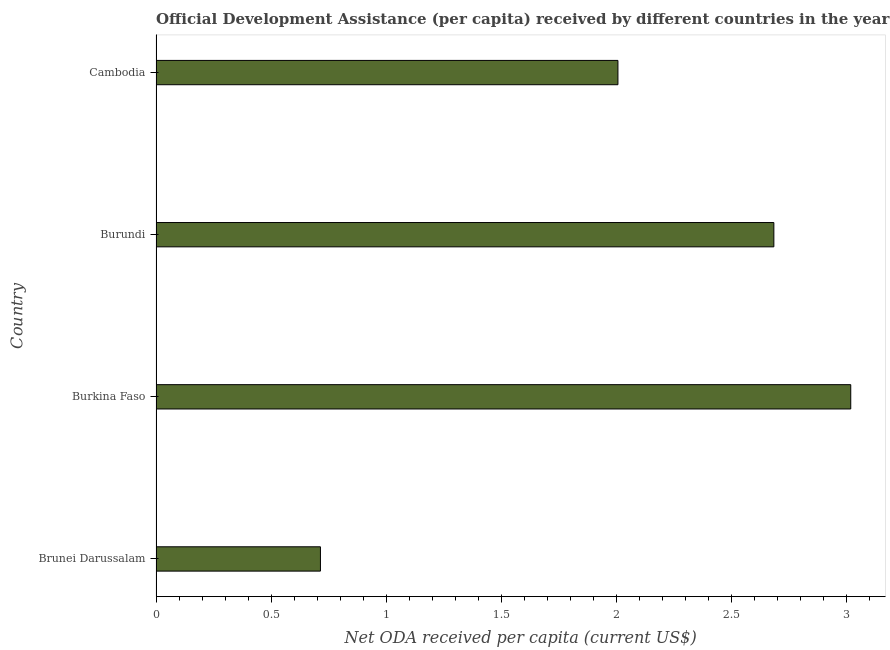What is the title of the graph?
Offer a very short reply. Official Development Assistance (per capita) received by different countries in the year 1964. What is the label or title of the X-axis?
Ensure brevity in your answer.  Net ODA received per capita (current US$). What is the label or title of the Y-axis?
Keep it short and to the point. Country. What is the net oda received per capita in Burundi?
Offer a very short reply. 2.69. Across all countries, what is the maximum net oda received per capita?
Provide a short and direct response. 3.02. Across all countries, what is the minimum net oda received per capita?
Offer a very short reply. 0.71. In which country was the net oda received per capita maximum?
Keep it short and to the point. Burkina Faso. In which country was the net oda received per capita minimum?
Keep it short and to the point. Brunei Darussalam. What is the sum of the net oda received per capita?
Make the answer very short. 8.43. What is the difference between the net oda received per capita in Burkina Faso and Cambodia?
Offer a terse response. 1.01. What is the average net oda received per capita per country?
Provide a short and direct response. 2.11. What is the median net oda received per capita?
Ensure brevity in your answer.  2.35. In how many countries, is the net oda received per capita greater than 1.9 US$?
Give a very brief answer. 3. What is the ratio of the net oda received per capita in Burundi to that in Cambodia?
Ensure brevity in your answer.  1.34. What is the difference between the highest and the second highest net oda received per capita?
Your response must be concise. 0.33. Is the sum of the net oda received per capita in Brunei Darussalam and Burkina Faso greater than the maximum net oda received per capita across all countries?
Keep it short and to the point. Yes. What is the difference between the highest and the lowest net oda received per capita?
Ensure brevity in your answer.  2.31. Are all the bars in the graph horizontal?
Keep it short and to the point. Yes. What is the difference between two consecutive major ticks on the X-axis?
Give a very brief answer. 0.5. What is the Net ODA received per capita (current US$) in Brunei Darussalam?
Your answer should be very brief. 0.71. What is the Net ODA received per capita (current US$) of Burkina Faso?
Offer a very short reply. 3.02. What is the Net ODA received per capita (current US$) in Burundi?
Offer a very short reply. 2.69. What is the Net ODA received per capita (current US$) in Cambodia?
Make the answer very short. 2.01. What is the difference between the Net ODA received per capita (current US$) in Brunei Darussalam and Burkina Faso?
Keep it short and to the point. -2.31. What is the difference between the Net ODA received per capita (current US$) in Brunei Darussalam and Burundi?
Keep it short and to the point. -1.97. What is the difference between the Net ODA received per capita (current US$) in Brunei Darussalam and Cambodia?
Your response must be concise. -1.29. What is the difference between the Net ODA received per capita (current US$) in Burkina Faso and Burundi?
Keep it short and to the point. 0.33. What is the difference between the Net ODA received per capita (current US$) in Burkina Faso and Cambodia?
Ensure brevity in your answer.  1.01. What is the difference between the Net ODA received per capita (current US$) in Burundi and Cambodia?
Your response must be concise. 0.68. What is the ratio of the Net ODA received per capita (current US$) in Brunei Darussalam to that in Burkina Faso?
Give a very brief answer. 0.24. What is the ratio of the Net ODA received per capita (current US$) in Brunei Darussalam to that in Burundi?
Your response must be concise. 0.27. What is the ratio of the Net ODA received per capita (current US$) in Brunei Darussalam to that in Cambodia?
Your response must be concise. 0.36. What is the ratio of the Net ODA received per capita (current US$) in Burkina Faso to that in Burundi?
Offer a very short reply. 1.12. What is the ratio of the Net ODA received per capita (current US$) in Burkina Faso to that in Cambodia?
Keep it short and to the point. 1.5. What is the ratio of the Net ODA received per capita (current US$) in Burundi to that in Cambodia?
Offer a terse response. 1.34. 